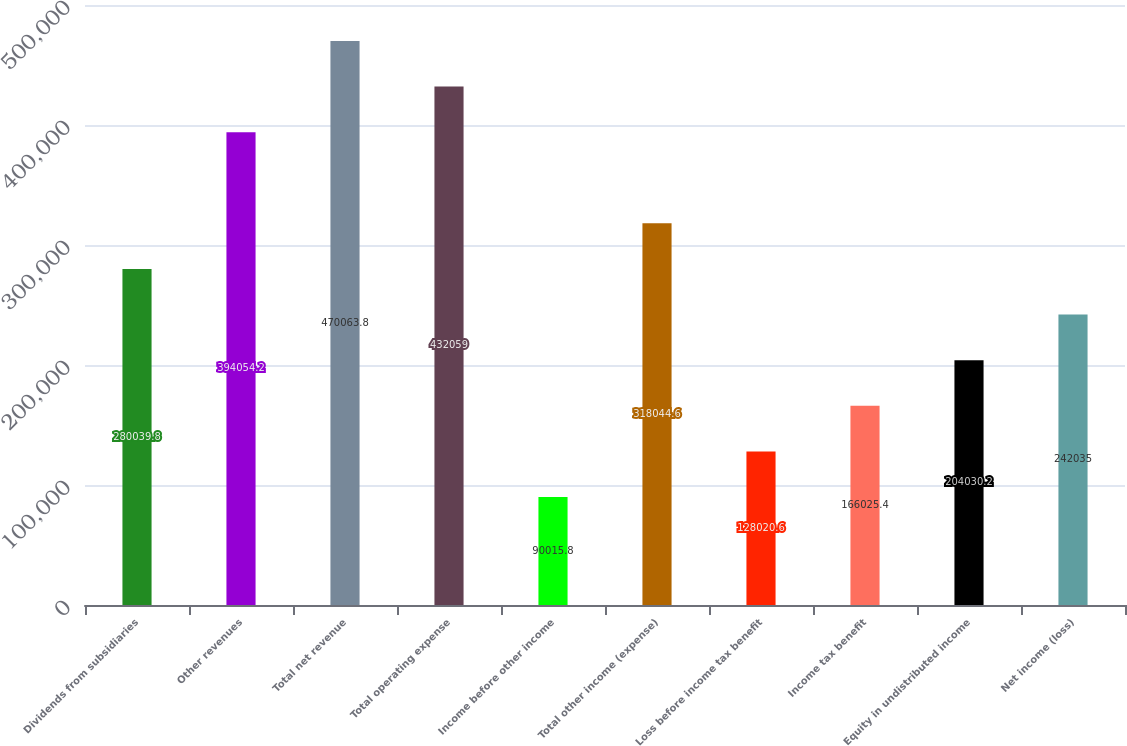<chart> <loc_0><loc_0><loc_500><loc_500><bar_chart><fcel>Dividends from subsidiaries<fcel>Other revenues<fcel>Total net revenue<fcel>Total operating expense<fcel>Income before other income<fcel>Total other income (expense)<fcel>Loss before income tax benefit<fcel>Income tax benefit<fcel>Equity in undistributed income<fcel>Net income (loss)<nl><fcel>280040<fcel>394054<fcel>470064<fcel>432059<fcel>90015.8<fcel>318045<fcel>128021<fcel>166025<fcel>204030<fcel>242035<nl></chart> 